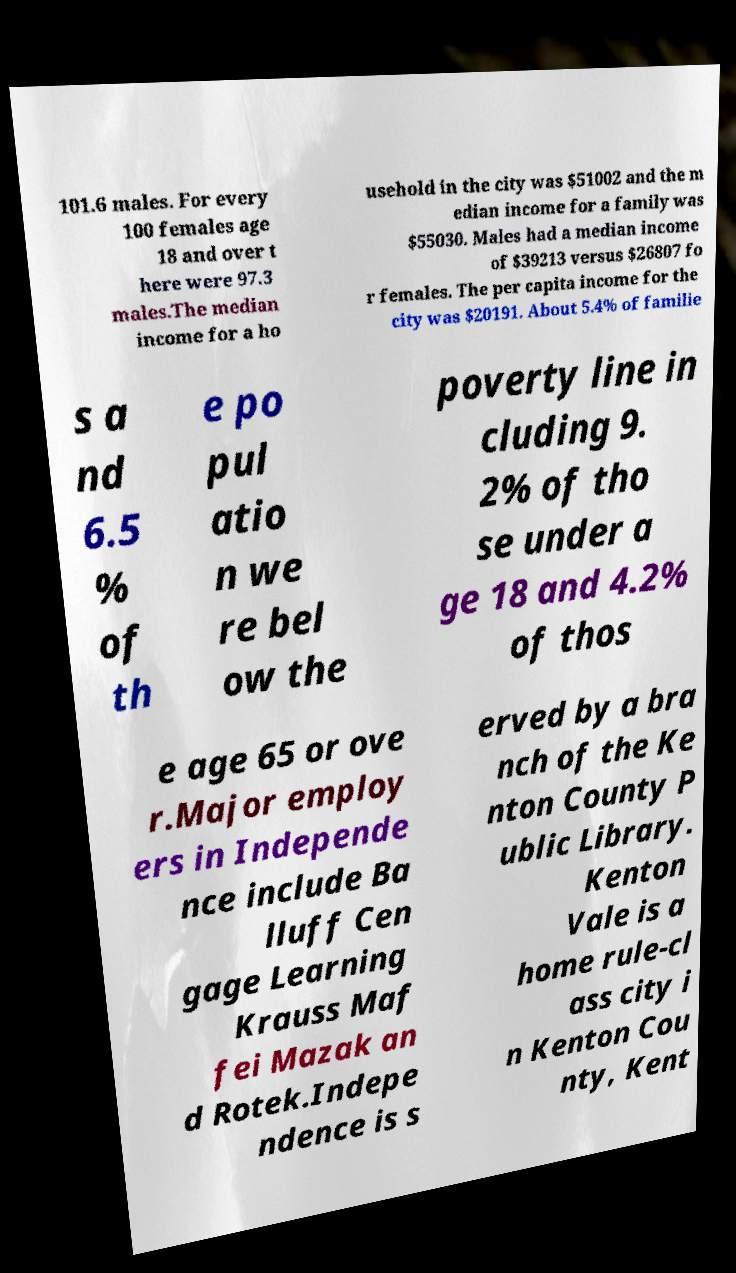What messages or text are displayed in this image? I need them in a readable, typed format. 101.6 males. For every 100 females age 18 and over t here were 97.3 males.The median income for a ho usehold in the city was $51002 and the m edian income for a family was $55030. Males had a median income of $39213 versus $26807 fo r females. The per capita income for the city was $20191. About 5.4% of familie s a nd 6.5 % of th e po pul atio n we re bel ow the poverty line in cluding 9. 2% of tho se under a ge 18 and 4.2% of thos e age 65 or ove r.Major employ ers in Independe nce include Ba lluff Cen gage Learning Krauss Maf fei Mazak an d Rotek.Indepe ndence is s erved by a bra nch of the Ke nton County P ublic Library. Kenton Vale is a home rule-cl ass city i n Kenton Cou nty, Kent 